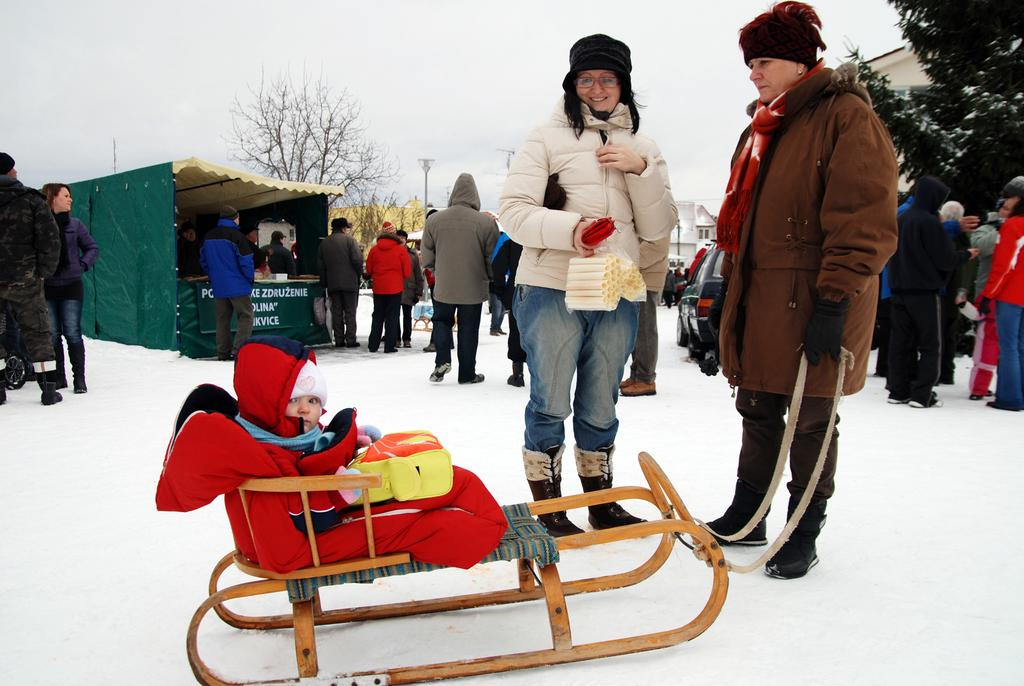What can be seen in the image in terms of human presence? There are people standing in the image. What type of structures are visible in the image? There are buildings in the image. What natural elements can be seen in the image? There are trees in the image. What is the baby on in the image? The baby is on a cart in the image. What is the ground covered with in the image? There is snow on the ground in the image. Is there any text visible in the image? Yes, there is text visible in the image. How would you describe the weather in the image? The sky is cloudy in the image, which suggests a potentially overcast or cold day. How many fans are visible in the image? There are no fans present in the image. What type of bone is being used as a decoration in the image? There is no bone present in the image. 